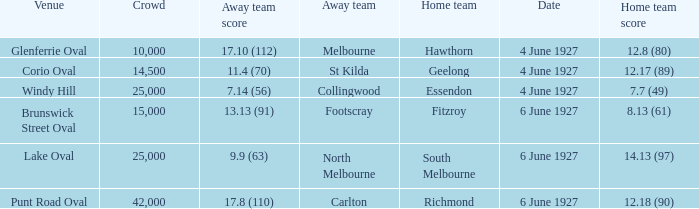How many people in the crowd with north melbourne as an away team? 25000.0. 